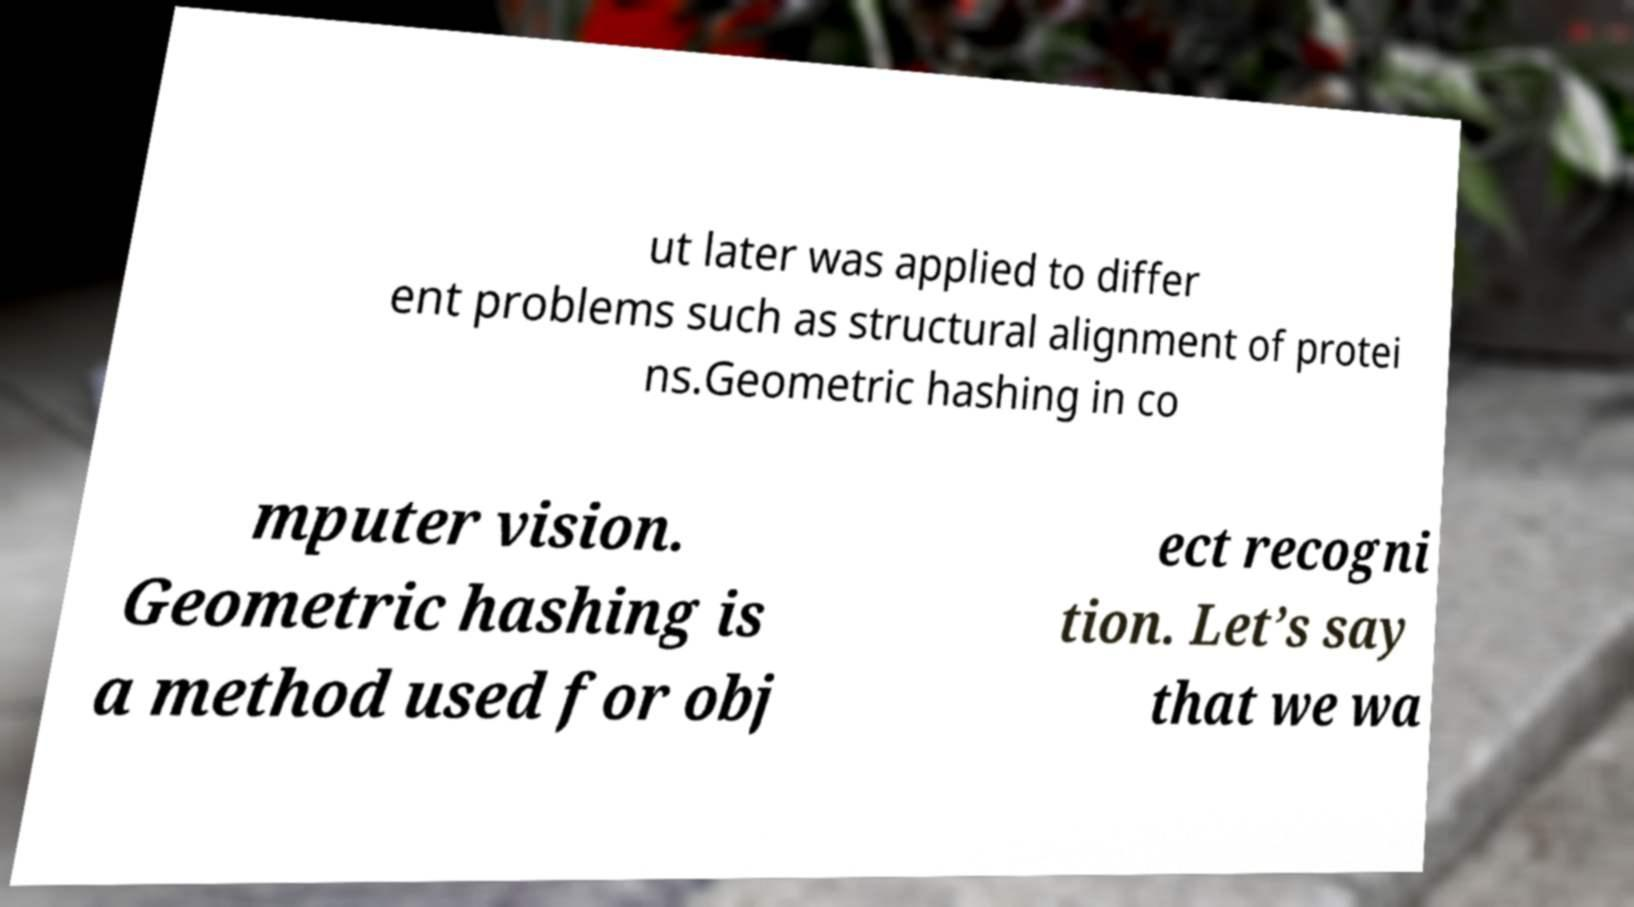Please identify and transcribe the text found in this image. ut later was applied to differ ent problems such as structural alignment of protei ns.Geometric hashing in co mputer vision. Geometric hashing is a method used for obj ect recogni tion. Let’s say that we wa 